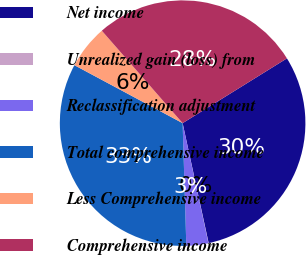Convert chart. <chart><loc_0><loc_0><loc_500><loc_500><pie_chart><fcel>Net income<fcel>Unrealized gain (loss) from<fcel>Reclassification adjustment<fcel>Total comprehensive income<fcel>Less Comprehensive income<fcel>Comprehensive income<nl><fcel>30.45%<fcel>0.03%<fcel>2.89%<fcel>33.31%<fcel>5.74%<fcel>27.59%<nl></chart> 